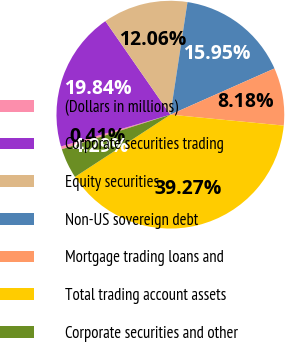Convert chart to OTSL. <chart><loc_0><loc_0><loc_500><loc_500><pie_chart><fcel>(Dollars in millions)<fcel>Corporate securities trading<fcel>Equity securities<fcel>Non-US sovereign debt<fcel>Mortgage trading loans and<fcel>Total trading account assets<fcel>Corporate securities and other<nl><fcel>0.41%<fcel>19.84%<fcel>12.06%<fcel>15.95%<fcel>8.18%<fcel>39.27%<fcel>4.29%<nl></chart> 